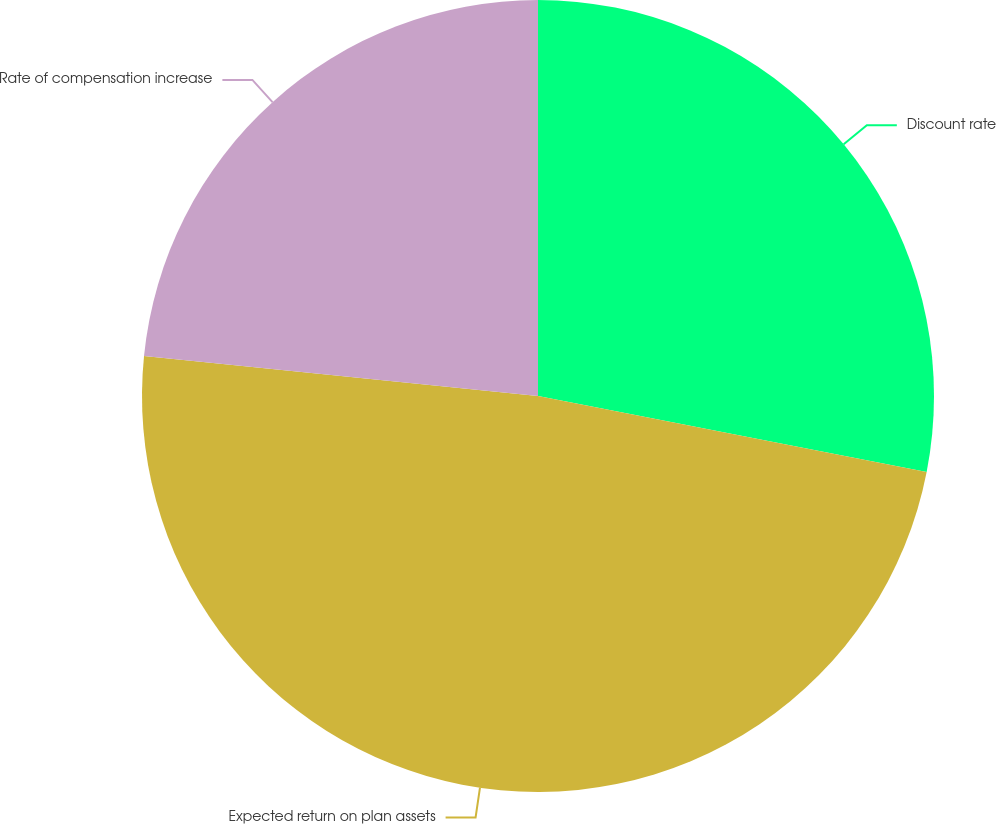Convert chart to OTSL. <chart><loc_0><loc_0><loc_500><loc_500><pie_chart><fcel>Discount rate<fcel>Expected return on plan assets<fcel>Rate of compensation increase<nl><fcel>28.07%<fcel>48.54%<fcel>23.39%<nl></chart> 